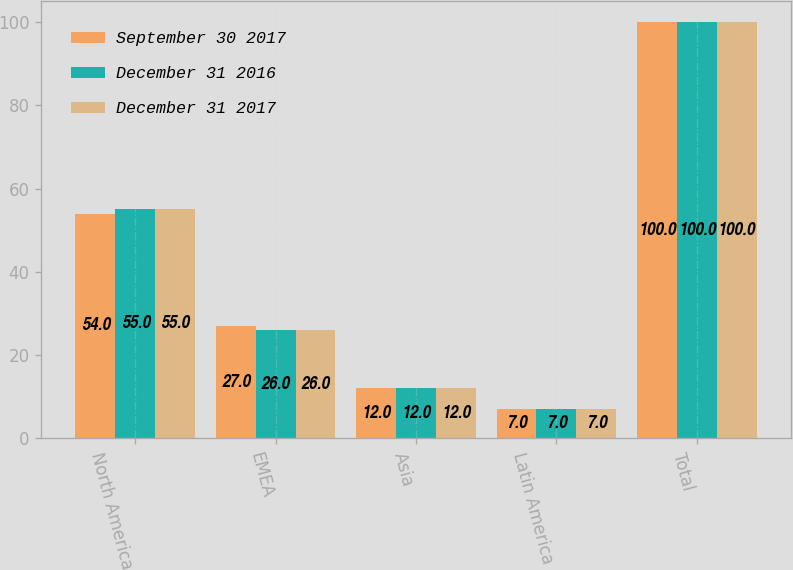Convert chart to OTSL. <chart><loc_0><loc_0><loc_500><loc_500><stacked_bar_chart><ecel><fcel>North America<fcel>EMEA<fcel>Asia<fcel>Latin America<fcel>Total<nl><fcel>September 30 2017<fcel>54<fcel>27<fcel>12<fcel>7<fcel>100<nl><fcel>December 31 2016<fcel>55<fcel>26<fcel>12<fcel>7<fcel>100<nl><fcel>December 31 2017<fcel>55<fcel>26<fcel>12<fcel>7<fcel>100<nl></chart> 